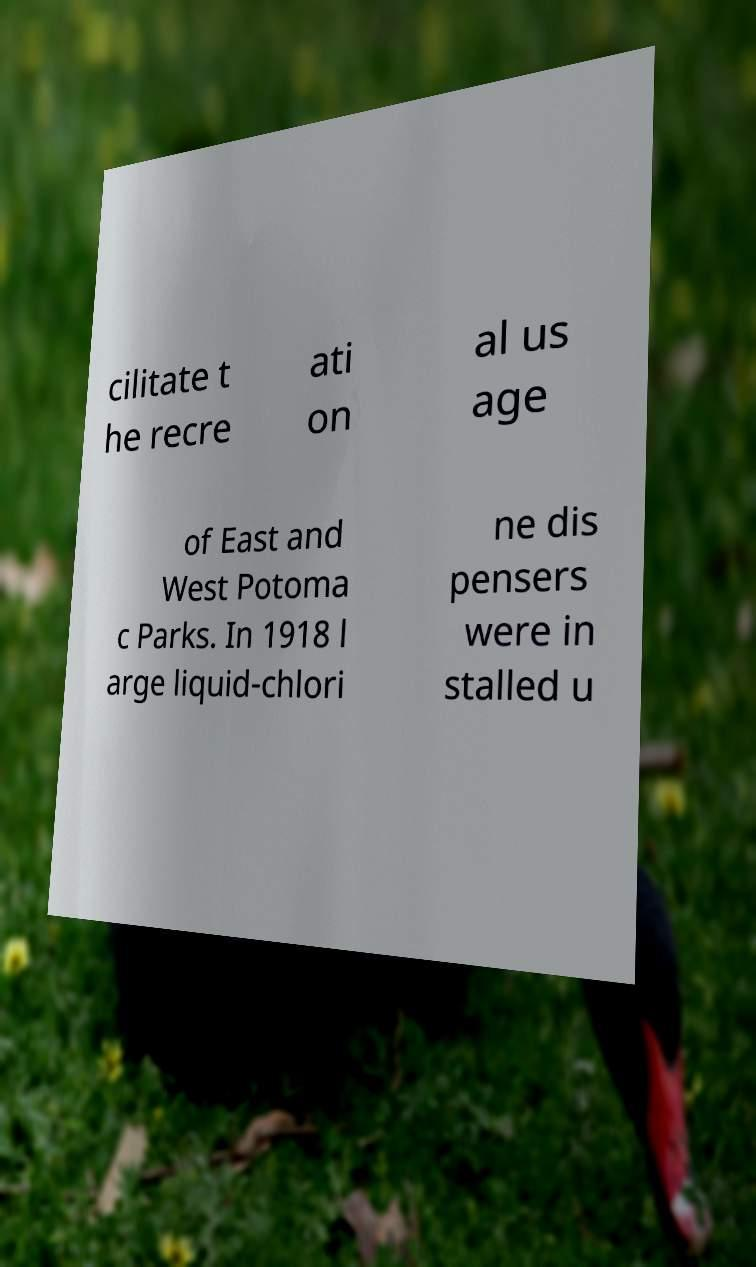What messages or text are displayed in this image? I need them in a readable, typed format. cilitate t he recre ati on al us age of East and West Potoma c Parks. In 1918 l arge liquid-chlori ne dis pensers were in stalled u 